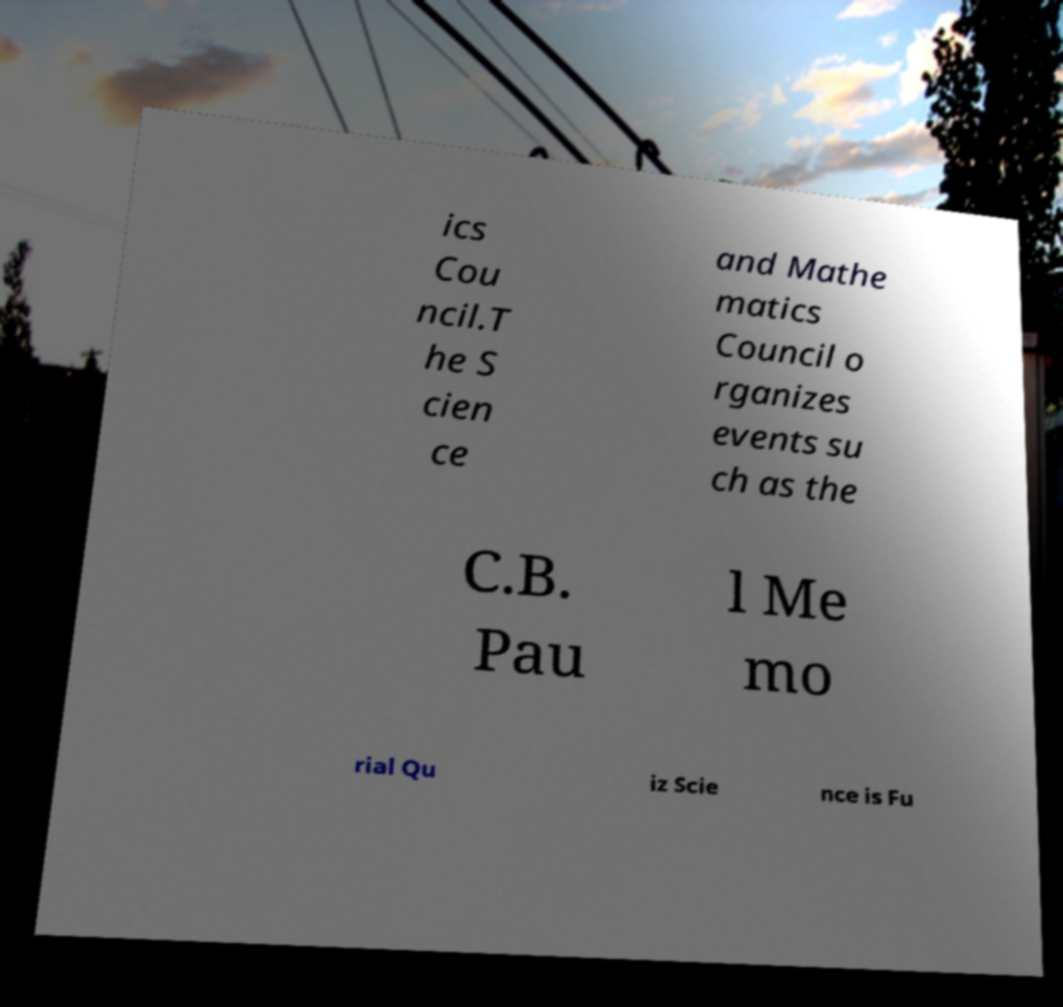Could you assist in decoding the text presented in this image and type it out clearly? ics Cou ncil.T he S cien ce and Mathe matics Council o rganizes events su ch as the C.B. Pau l Me mo rial Qu iz Scie nce is Fu 